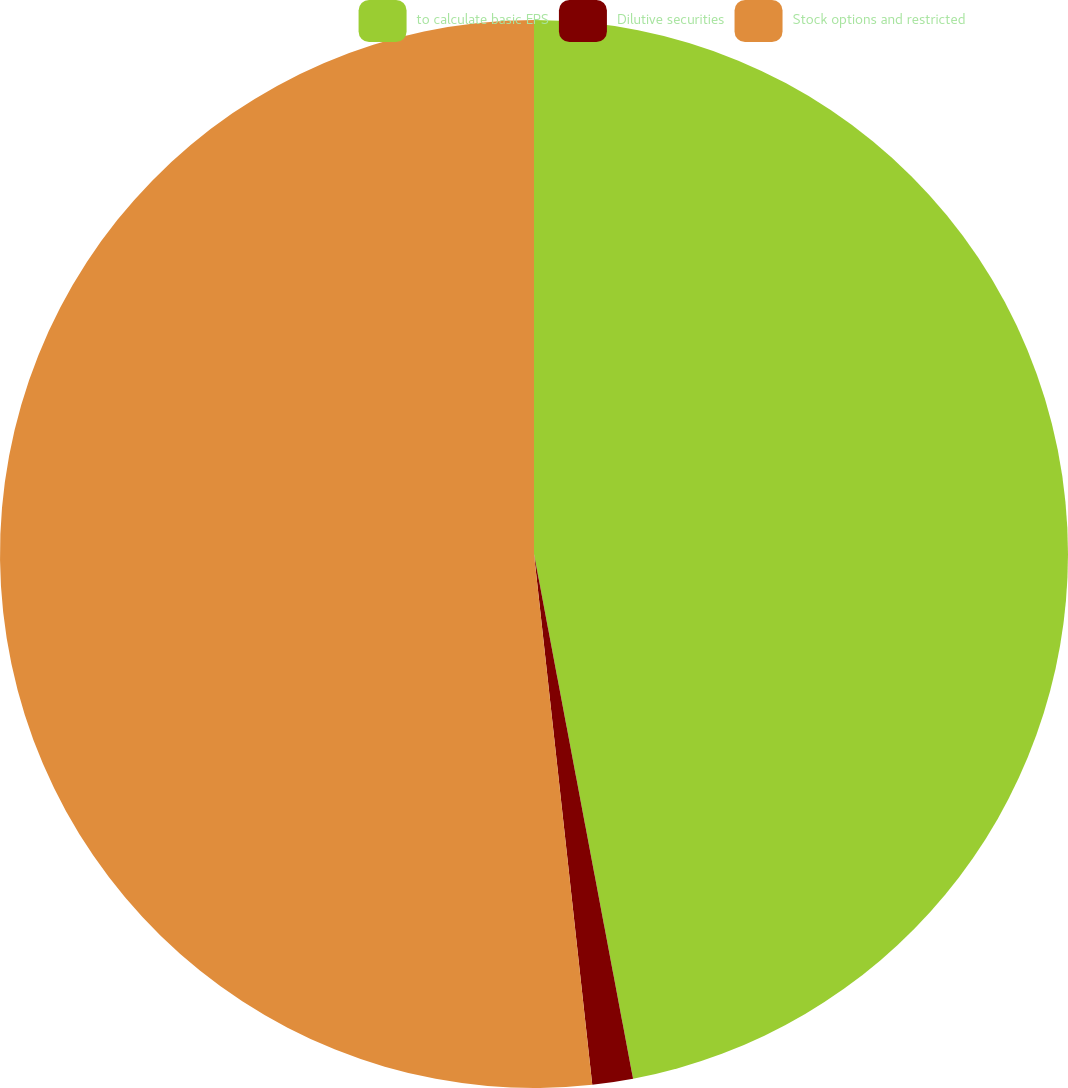Convert chart. <chart><loc_0><loc_0><loc_500><loc_500><pie_chart><fcel>to calculate basic EPS<fcel>Dilutive securities<fcel>Stock options and restricted<nl><fcel>47.03%<fcel>1.23%<fcel>51.74%<nl></chart> 